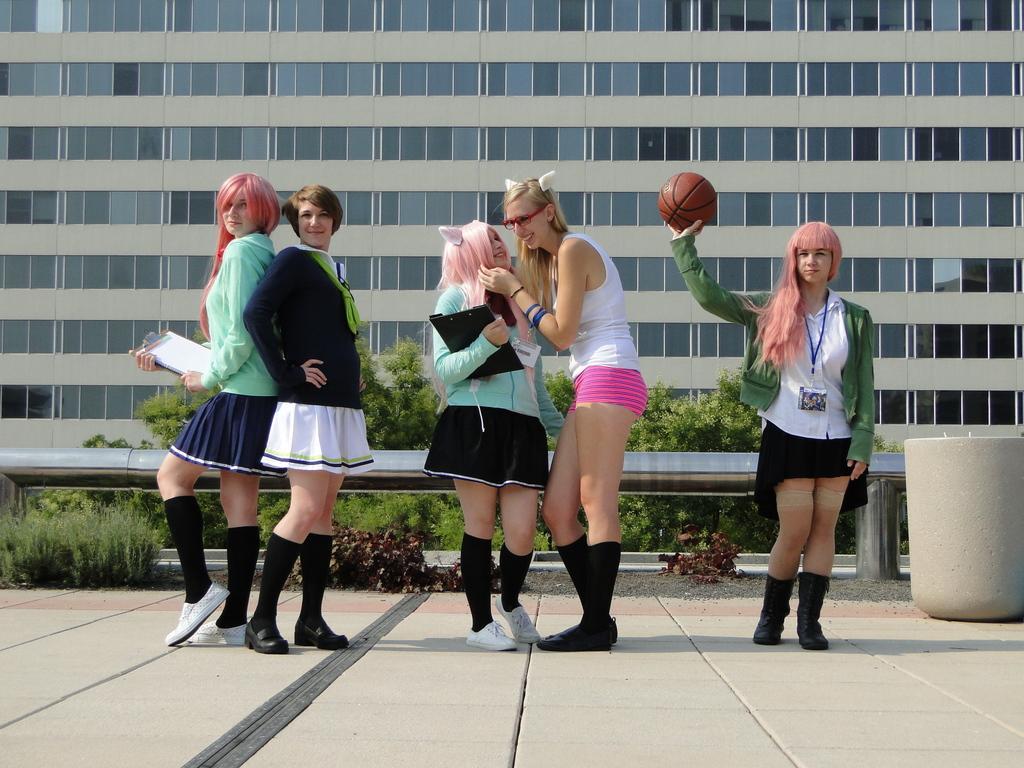Could you give a brief overview of what you see in this image? In this image I can see five women's are standing on the road and are holding a ball, file and a pad in hand. In the background I can see planets, pipe, trees and a building. This image is taken during a day. 